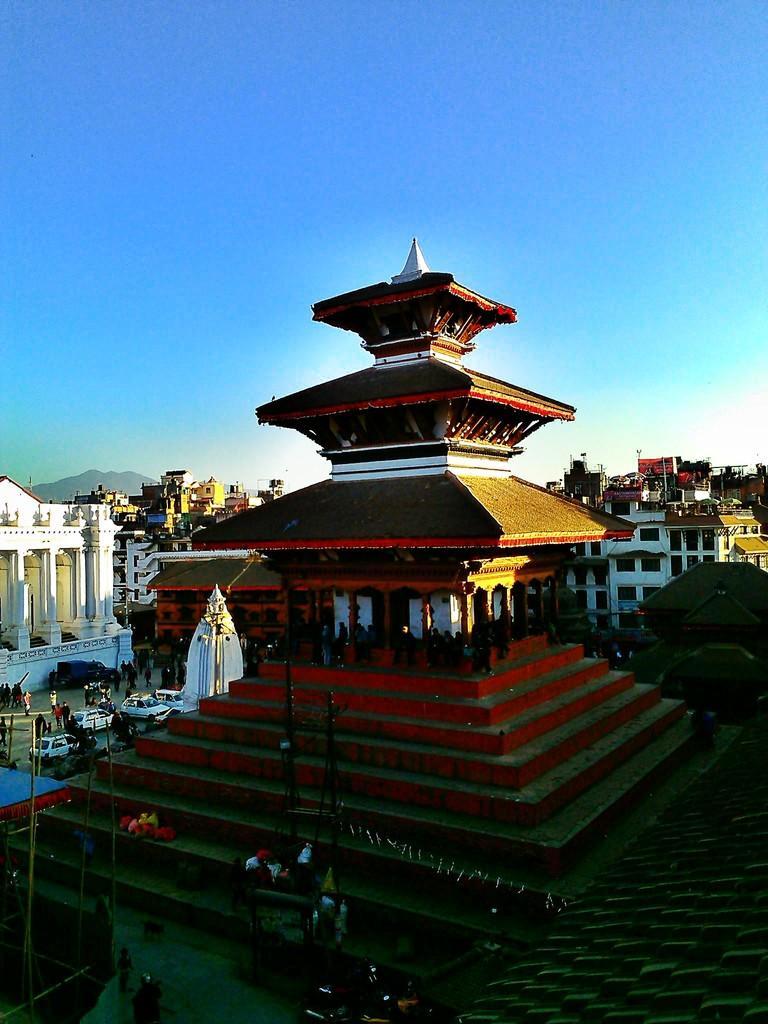Please provide a concise description of this image. This looks like a pagoda. These are the stairs. I can see groups of people sitting. These are the cars, which are parked. I can see the building with windows and pillars. Here there are groups of people. 